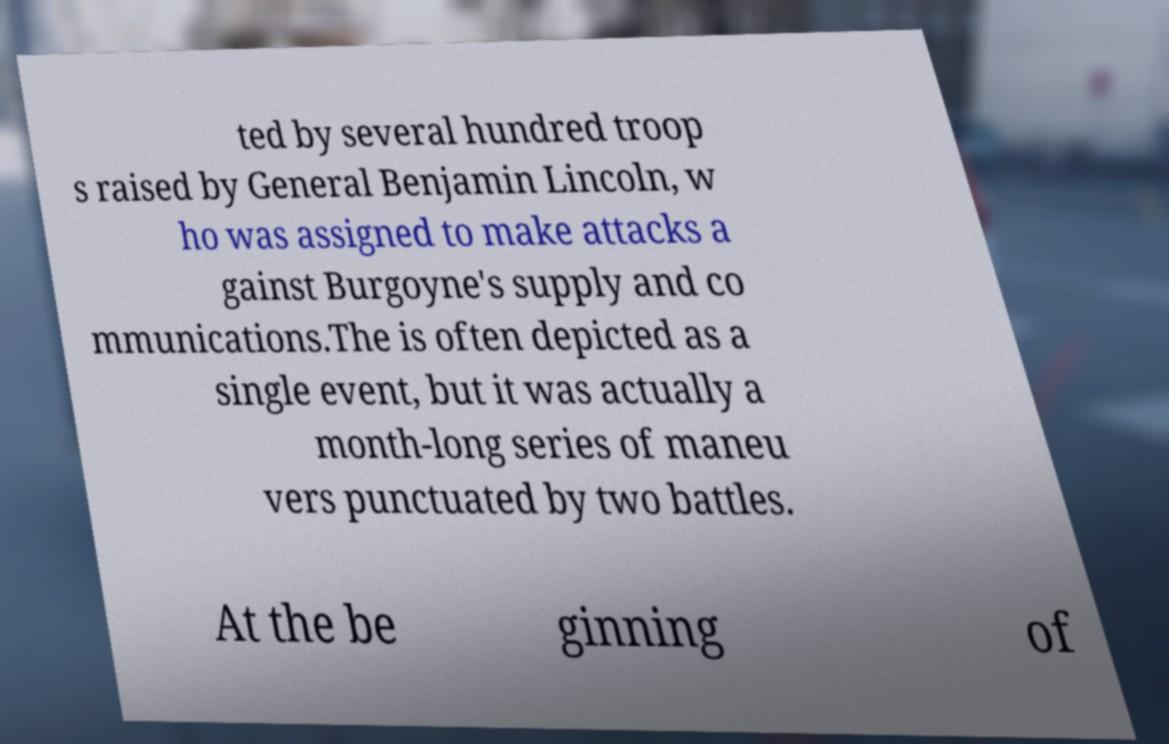What messages or text are displayed in this image? I need them in a readable, typed format. ted by several hundred troop s raised by General Benjamin Lincoln, w ho was assigned to make attacks a gainst Burgoyne's supply and co mmunications.The is often depicted as a single event, but it was actually a month-long series of maneu vers punctuated by two battles. At the be ginning of 